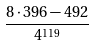Convert formula to latex. <formula><loc_0><loc_0><loc_500><loc_500>\frac { 8 \cdot 3 9 6 - 4 9 2 } { 4 ^ { 1 1 9 } }</formula> 